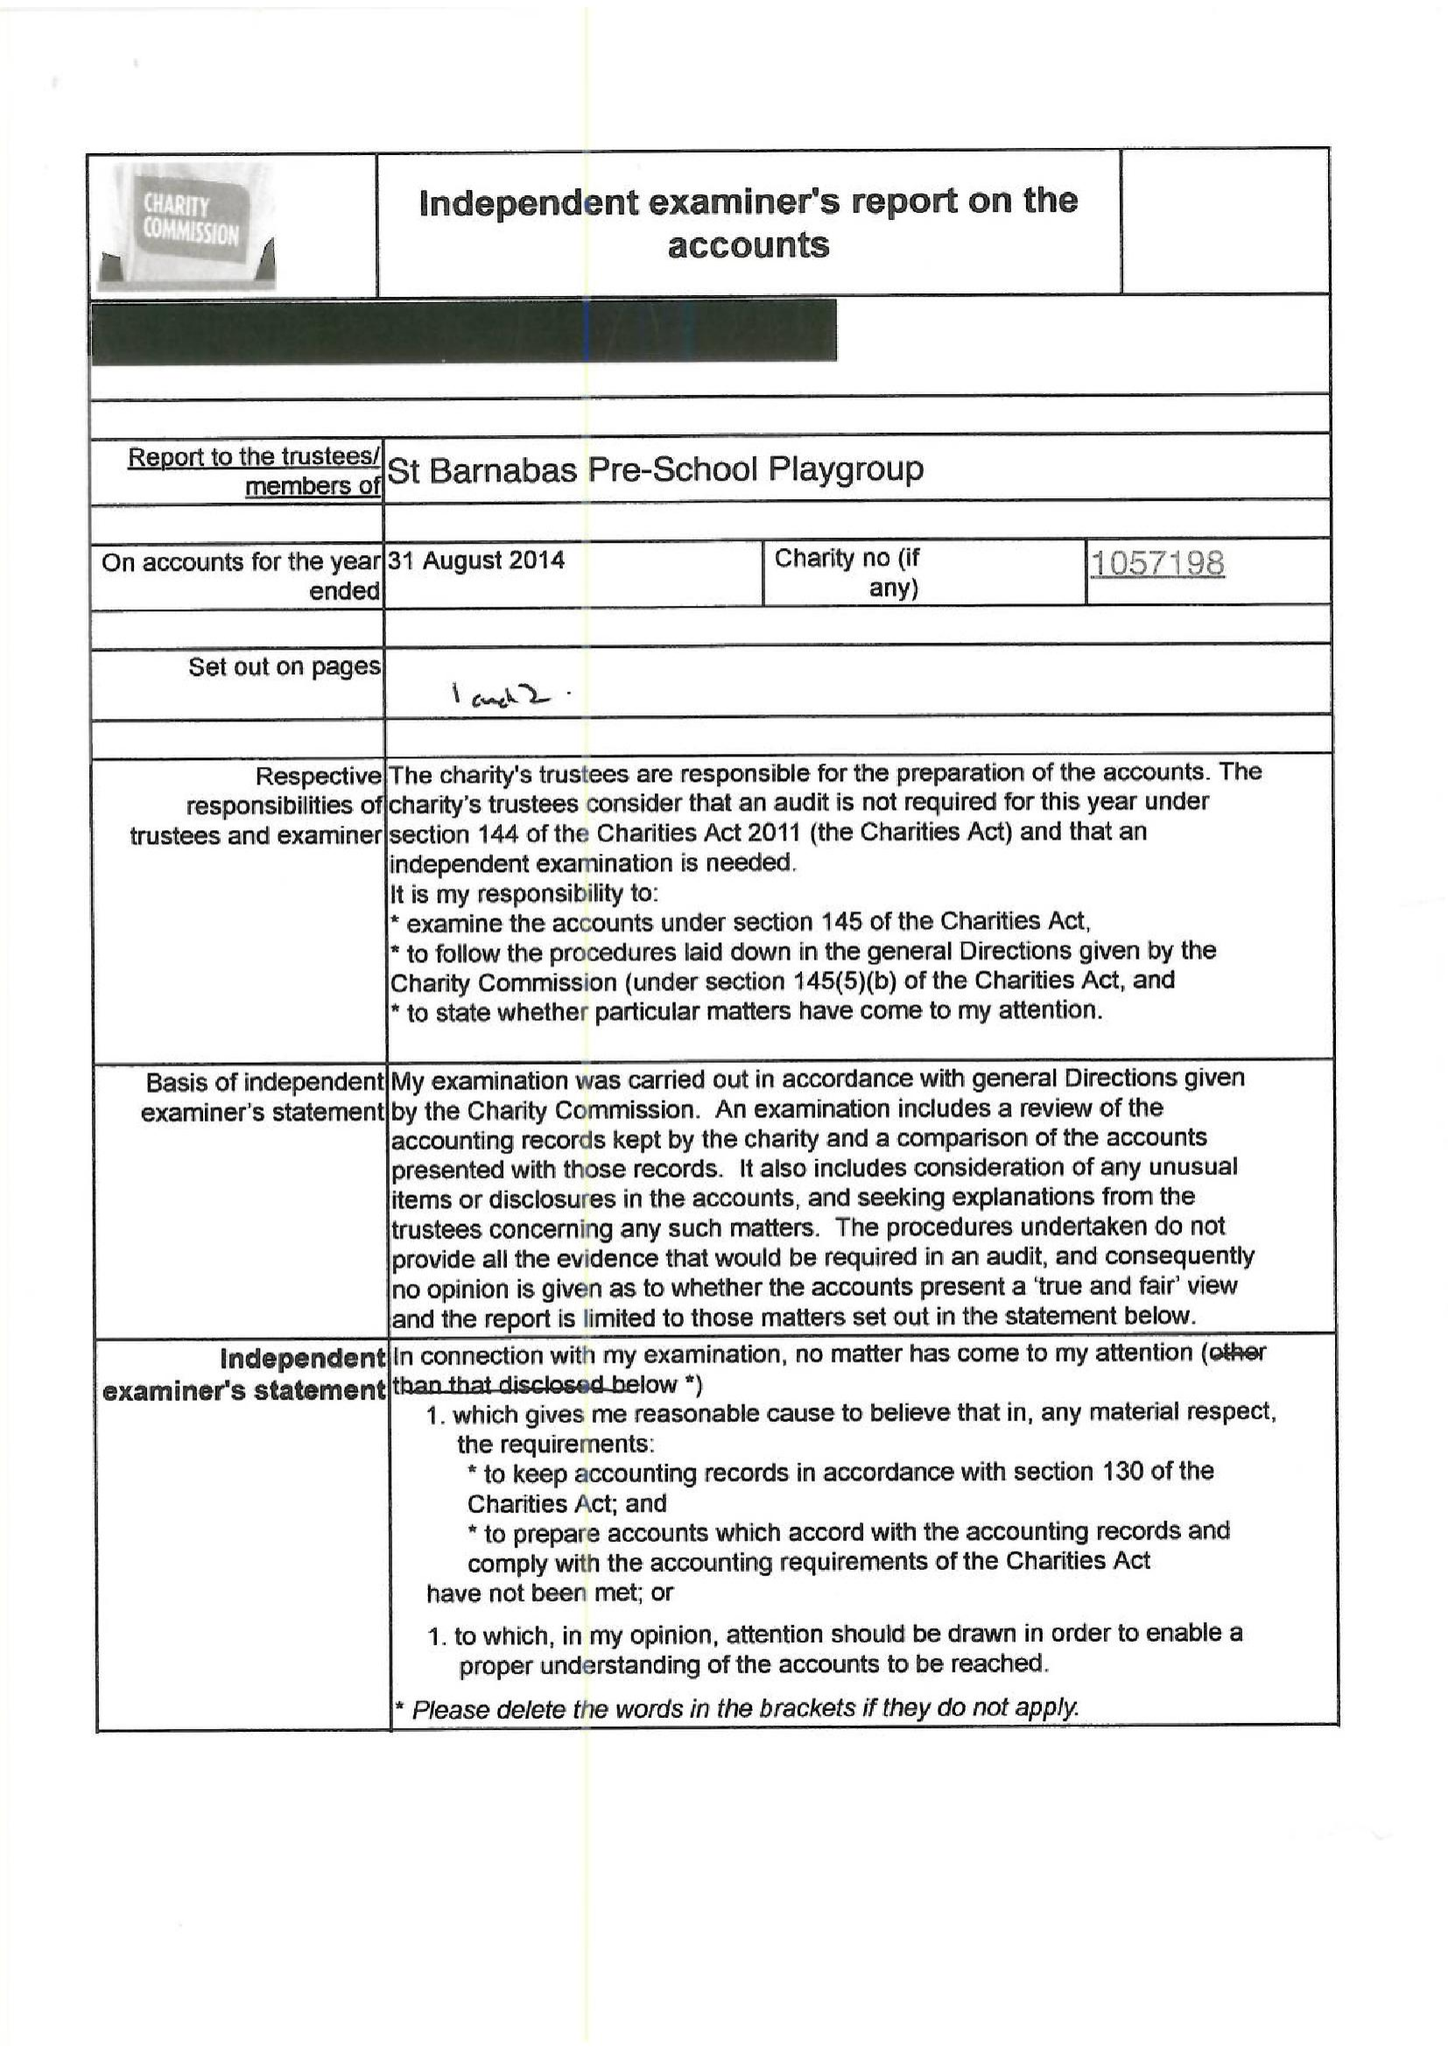What is the value for the income_annually_in_british_pounds?
Answer the question using a single word or phrase. 52638.00 